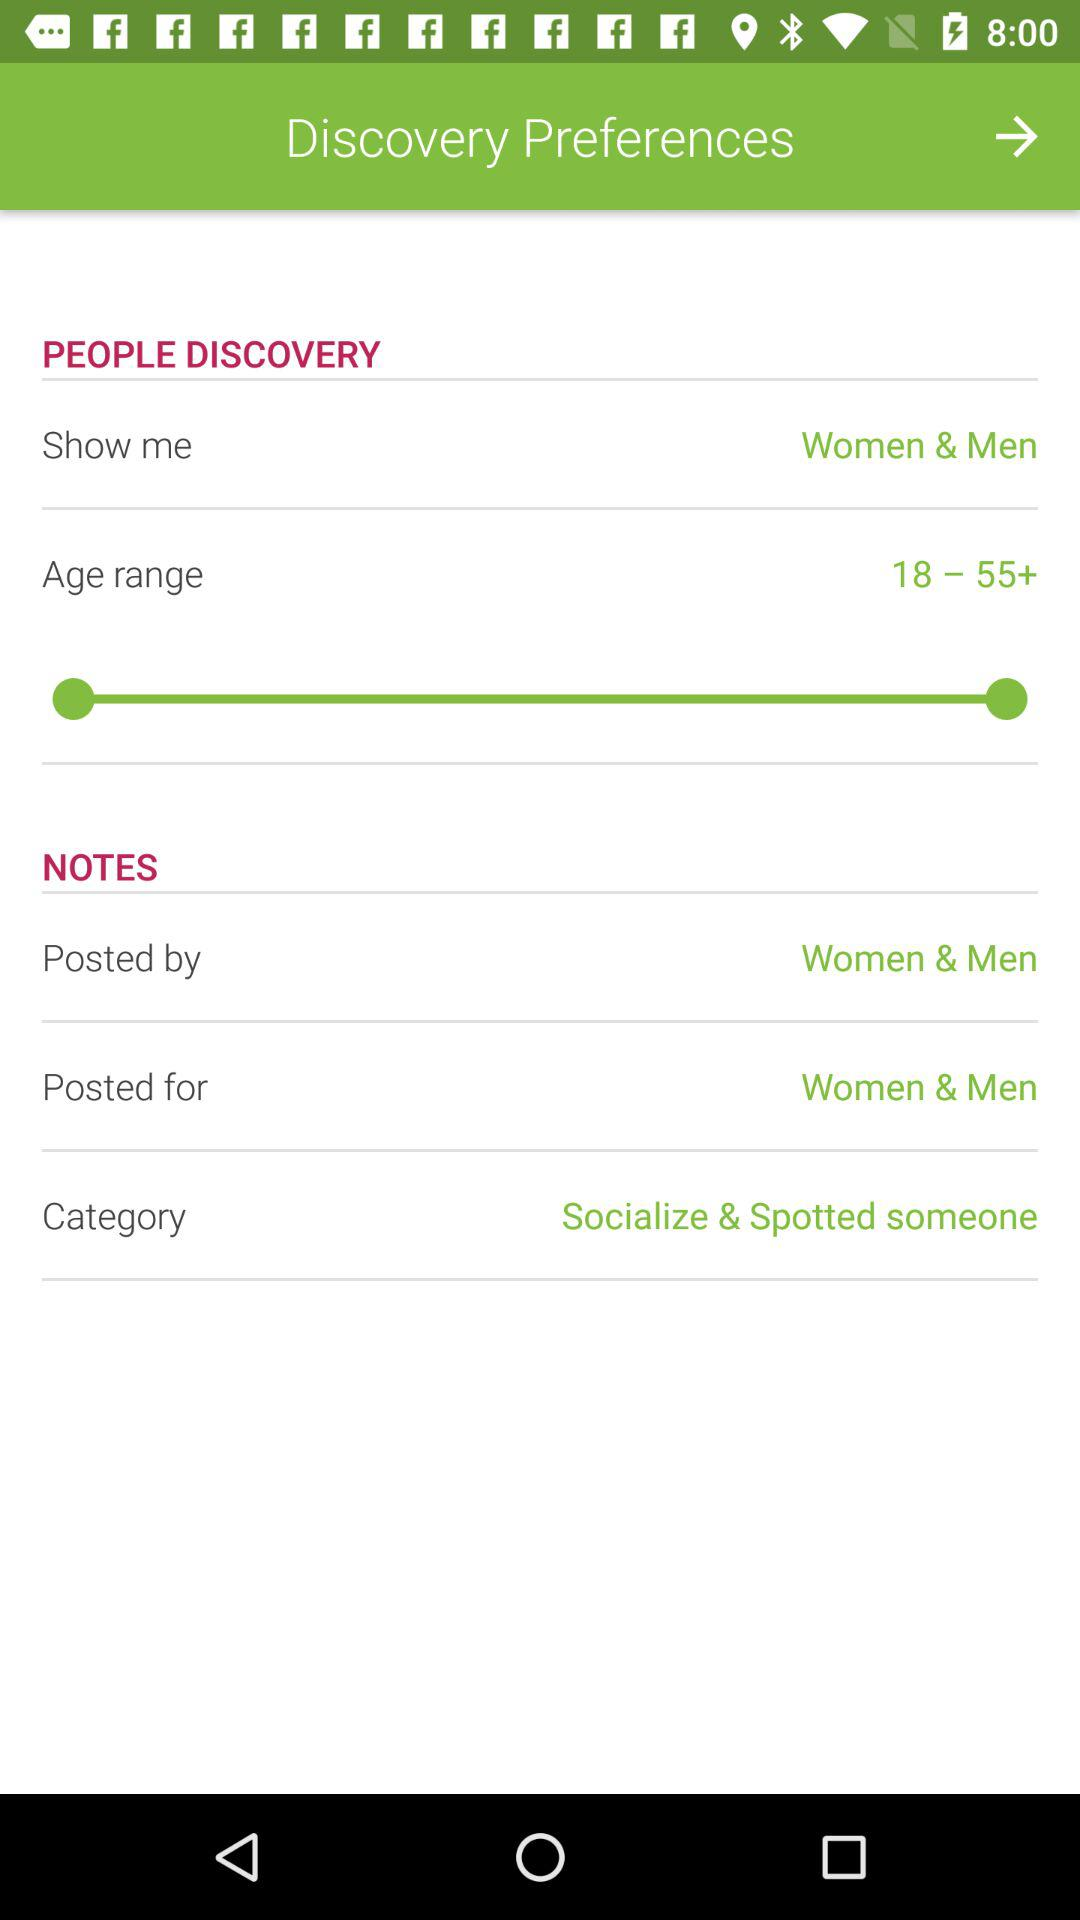What is the category? The category is "Socialize & Spotted someone". 